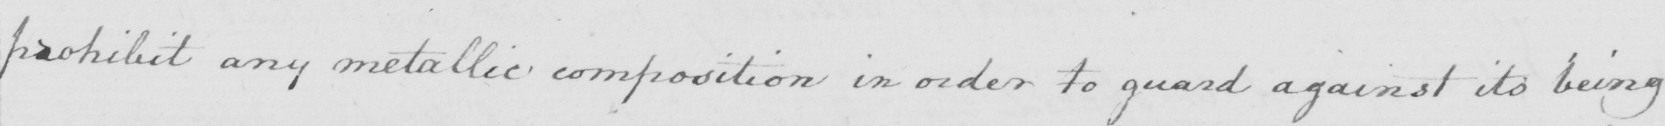Please transcribe the handwritten text in this image. prohibit any metallic composition in order to guard against its being 